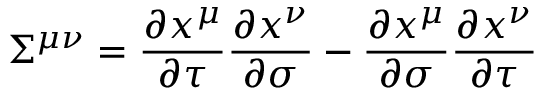Convert formula to latex. <formula><loc_0><loc_0><loc_500><loc_500>{ \Sigma } ^ { \mu \nu } = \frac { \partial x ^ { \mu } } { \partial \tau } \frac { \partial x ^ { \nu } } { \partial \sigma } - \frac { \partial x ^ { \mu } } { \partial \sigma } \frac { \partial x ^ { \nu } } { \partial \tau }</formula> 